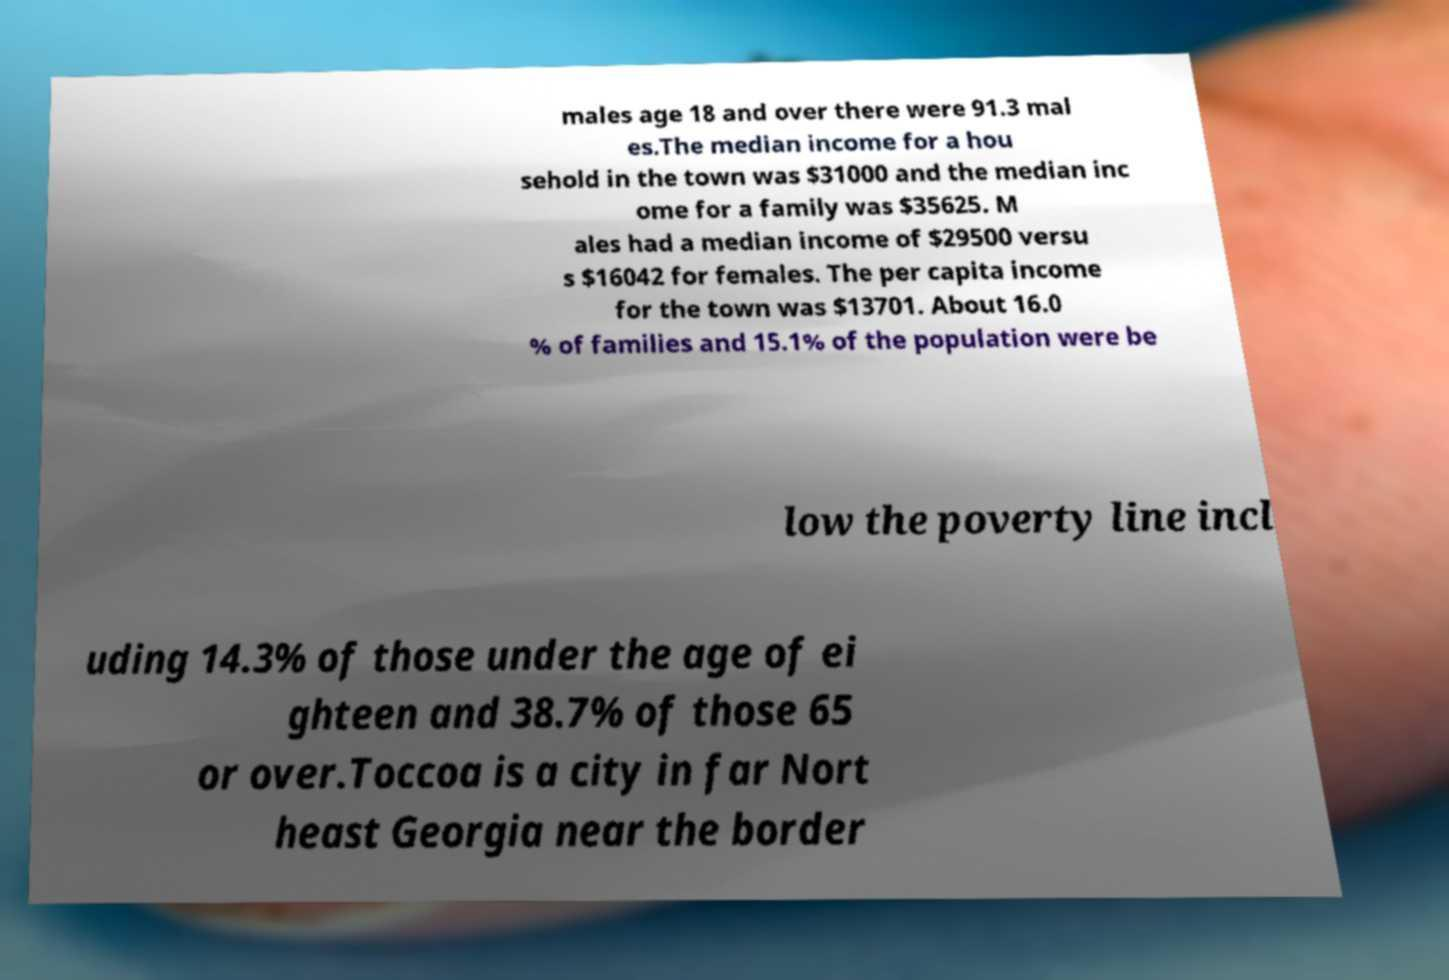I need the written content from this picture converted into text. Can you do that? males age 18 and over there were 91.3 mal es.The median income for a hou sehold in the town was $31000 and the median inc ome for a family was $35625. M ales had a median income of $29500 versu s $16042 for females. The per capita income for the town was $13701. About 16.0 % of families and 15.1% of the population were be low the poverty line incl uding 14.3% of those under the age of ei ghteen and 38.7% of those 65 or over.Toccoa is a city in far Nort heast Georgia near the border 